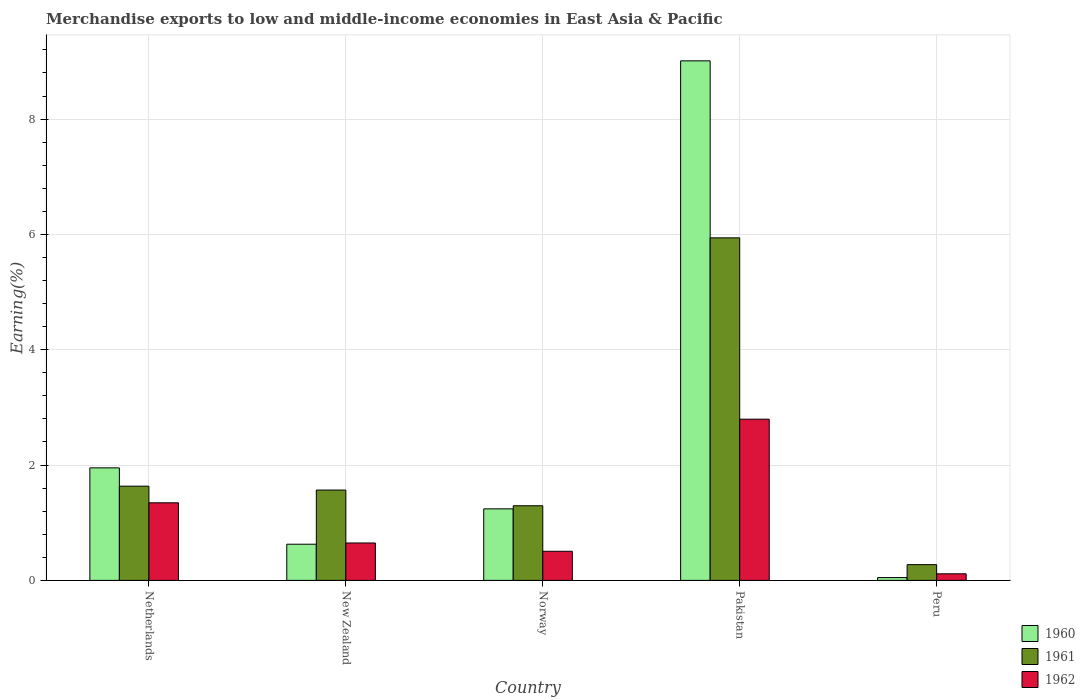How many groups of bars are there?
Give a very brief answer. 5. Are the number of bars per tick equal to the number of legend labels?
Offer a terse response. Yes. How many bars are there on the 2nd tick from the left?
Ensure brevity in your answer.  3. What is the label of the 5th group of bars from the left?
Your answer should be compact. Peru. In how many cases, is the number of bars for a given country not equal to the number of legend labels?
Make the answer very short. 0. What is the percentage of amount earned from merchandise exports in 1962 in Peru?
Your answer should be very brief. 0.11. Across all countries, what is the maximum percentage of amount earned from merchandise exports in 1962?
Offer a very short reply. 2.8. Across all countries, what is the minimum percentage of amount earned from merchandise exports in 1961?
Ensure brevity in your answer.  0.27. What is the total percentage of amount earned from merchandise exports in 1961 in the graph?
Offer a very short reply. 10.71. What is the difference between the percentage of amount earned from merchandise exports in 1961 in New Zealand and that in Pakistan?
Offer a very short reply. -4.37. What is the difference between the percentage of amount earned from merchandise exports in 1960 in New Zealand and the percentage of amount earned from merchandise exports in 1962 in Netherlands?
Ensure brevity in your answer.  -0.72. What is the average percentage of amount earned from merchandise exports in 1960 per country?
Provide a short and direct response. 2.58. What is the difference between the percentage of amount earned from merchandise exports of/in 1962 and percentage of amount earned from merchandise exports of/in 1960 in Norway?
Make the answer very short. -0.74. What is the ratio of the percentage of amount earned from merchandise exports in 1962 in New Zealand to that in Peru?
Your response must be concise. 5.69. Is the percentage of amount earned from merchandise exports in 1962 in Norway less than that in Pakistan?
Provide a succinct answer. Yes. What is the difference between the highest and the second highest percentage of amount earned from merchandise exports in 1960?
Make the answer very short. 7.77. What is the difference between the highest and the lowest percentage of amount earned from merchandise exports in 1960?
Provide a short and direct response. 8.96. Is the sum of the percentage of amount earned from merchandise exports in 1962 in Pakistan and Peru greater than the maximum percentage of amount earned from merchandise exports in 1960 across all countries?
Offer a terse response. No. How many countries are there in the graph?
Your response must be concise. 5. What is the difference between two consecutive major ticks on the Y-axis?
Offer a terse response. 2. Does the graph contain any zero values?
Ensure brevity in your answer.  No. Where does the legend appear in the graph?
Offer a terse response. Bottom right. What is the title of the graph?
Provide a succinct answer. Merchandise exports to low and middle-income economies in East Asia & Pacific. Does "1999" appear as one of the legend labels in the graph?
Make the answer very short. No. What is the label or title of the Y-axis?
Provide a short and direct response. Earning(%). What is the Earning(%) in 1960 in Netherlands?
Offer a terse response. 1.95. What is the Earning(%) in 1961 in Netherlands?
Offer a terse response. 1.63. What is the Earning(%) in 1962 in Netherlands?
Your response must be concise. 1.35. What is the Earning(%) of 1960 in New Zealand?
Provide a short and direct response. 0.63. What is the Earning(%) in 1961 in New Zealand?
Offer a very short reply. 1.57. What is the Earning(%) of 1962 in New Zealand?
Give a very brief answer. 0.65. What is the Earning(%) in 1960 in Norway?
Your answer should be compact. 1.24. What is the Earning(%) in 1961 in Norway?
Keep it short and to the point. 1.29. What is the Earning(%) of 1962 in Norway?
Provide a succinct answer. 0.5. What is the Earning(%) of 1960 in Pakistan?
Your response must be concise. 9.01. What is the Earning(%) in 1961 in Pakistan?
Your answer should be compact. 5.94. What is the Earning(%) in 1962 in Pakistan?
Give a very brief answer. 2.8. What is the Earning(%) of 1960 in Peru?
Your answer should be compact. 0.05. What is the Earning(%) of 1961 in Peru?
Make the answer very short. 0.27. What is the Earning(%) in 1962 in Peru?
Provide a succinct answer. 0.11. Across all countries, what is the maximum Earning(%) of 1960?
Offer a very short reply. 9.01. Across all countries, what is the maximum Earning(%) of 1961?
Your response must be concise. 5.94. Across all countries, what is the maximum Earning(%) in 1962?
Offer a very short reply. 2.8. Across all countries, what is the minimum Earning(%) of 1960?
Give a very brief answer. 0.05. Across all countries, what is the minimum Earning(%) of 1961?
Keep it short and to the point. 0.27. Across all countries, what is the minimum Earning(%) in 1962?
Your answer should be compact. 0.11. What is the total Earning(%) in 1960 in the graph?
Make the answer very short. 12.88. What is the total Earning(%) of 1961 in the graph?
Offer a very short reply. 10.71. What is the total Earning(%) in 1962 in the graph?
Provide a succinct answer. 5.41. What is the difference between the Earning(%) of 1960 in Netherlands and that in New Zealand?
Ensure brevity in your answer.  1.32. What is the difference between the Earning(%) of 1961 in Netherlands and that in New Zealand?
Offer a terse response. 0.07. What is the difference between the Earning(%) of 1962 in Netherlands and that in New Zealand?
Keep it short and to the point. 0.7. What is the difference between the Earning(%) of 1960 in Netherlands and that in Norway?
Your answer should be compact. 0.71. What is the difference between the Earning(%) in 1961 in Netherlands and that in Norway?
Your answer should be compact. 0.34. What is the difference between the Earning(%) of 1962 in Netherlands and that in Norway?
Offer a terse response. 0.84. What is the difference between the Earning(%) of 1960 in Netherlands and that in Pakistan?
Ensure brevity in your answer.  -7.06. What is the difference between the Earning(%) in 1961 in Netherlands and that in Pakistan?
Provide a short and direct response. -4.31. What is the difference between the Earning(%) of 1962 in Netherlands and that in Pakistan?
Your answer should be very brief. -1.45. What is the difference between the Earning(%) of 1960 in Netherlands and that in Peru?
Ensure brevity in your answer.  1.9. What is the difference between the Earning(%) in 1961 in Netherlands and that in Peru?
Keep it short and to the point. 1.36. What is the difference between the Earning(%) in 1962 in Netherlands and that in Peru?
Make the answer very short. 1.23. What is the difference between the Earning(%) in 1960 in New Zealand and that in Norway?
Provide a succinct answer. -0.61. What is the difference between the Earning(%) of 1961 in New Zealand and that in Norway?
Your answer should be compact. 0.27. What is the difference between the Earning(%) of 1962 in New Zealand and that in Norway?
Your answer should be compact. 0.14. What is the difference between the Earning(%) in 1960 in New Zealand and that in Pakistan?
Offer a terse response. -8.38. What is the difference between the Earning(%) in 1961 in New Zealand and that in Pakistan?
Give a very brief answer. -4.37. What is the difference between the Earning(%) of 1962 in New Zealand and that in Pakistan?
Offer a terse response. -2.15. What is the difference between the Earning(%) of 1960 in New Zealand and that in Peru?
Offer a terse response. 0.58. What is the difference between the Earning(%) of 1961 in New Zealand and that in Peru?
Your answer should be compact. 1.29. What is the difference between the Earning(%) in 1962 in New Zealand and that in Peru?
Make the answer very short. 0.53. What is the difference between the Earning(%) in 1960 in Norway and that in Pakistan?
Make the answer very short. -7.77. What is the difference between the Earning(%) in 1961 in Norway and that in Pakistan?
Ensure brevity in your answer.  -4.65. What is the difference between the Earning(%) in 1962 in Norway and that in Pakistan?
Your response must be concise. -2.29. What is the difference between the Earning(%) in 1960 in Norway and that in Peru?
Provide a succinct answer. 1.19. What is the difference between the Earning(%) in 1961 in Norway and that in Peru?
Your response must be concise. 1.02. What is the difference between the Earning(%) of 1962 in Norway and that in Peru?
Your answer should be very brief. 0.39. What is the difference between the Earning(%) in 1960 in Pakistan and that in Peru?
Give a very brief answer. 8.96. What is the difference between the Earning(%) in 1961 in Pakistan and that in Peru?
Offer a terse response. 5.67. What is the difference between the Earning(%) of 1962 in Pakistan and that in Peru?
Offer a terse response. 2.68. What is the difference between the Earning(%) of 1960 in Netherlands and the Earning(%) of 1961 in New Zealand?
Provide a short and direct response. 0.39. What is the difference between the Earning(%) in 1960 in Netherlands and the Earning(%) in 1962 in New Zealand?
Offer a very short reply. 1.3. What is the difference between the Earning(%) in 1960 in Netherlands and the Earning(%) in 1961 in Norway?
Your response must be concise. 0.66. What is the difference between the Earning(%) in 1960 in Netherlands and the Earning(%) in 1962 in Norway?
Make the answer very short. 1.45. What is the difference between the Earning(%) of 1961 in Netherlands and the Earning(%) of 1962 in Norway?
Your response must be concise. 1.13. What is the difference between the Earning(%) of 1960 in Netherlands and the Earning(%) of 1961 in Pakistan?
Ensure brevity in your answer.  -3.99. What is the difference between the Earning(%) of 1960 in Netherlands and the Earning(%) of 1962 in Pakistan?
Keep it short and to the point. -0.84. What is the difference between the Earning(%) of 1961 in Netherlands and the Earning(%) of 1962 in Pakistan?
Keep it short and to the point. -1.16. What is the difference between the Earning(%) of 1960 in Netherlands and the Earning(%) of 1961 in Peru?
Ensure brevity in your answer.  1.68. What is the difference between the Earning(%) in 1960 in Netherlands and the Earning(%) in 1962 in Peru?
Make the answer very short. 1.84. What is the difference between the Earning(%) of 1961 in Netherlands and the Earning(%) of 1962 in Peru?
Offer a terse response. 1.52. What is the difference between the Earning(%) in 1960 in New Zealand and the Earning(%) in 1961 in Norway?
Your response must be concise. -0.67. What is the difference between the Earning(%) in 1960 in New Zealand and the Earning(%) in 1962 in Norway?
Provide a short and direct response. 0.12. What is the difference between the Earning(%) in 1961 in New Zealand and the Earning(%) in 1962 in Norway?
Provide a short and direct response. 1.06. What is the difference between the Earning(%) in 1960 in New Zealand and the Earning(%) in 1961 in Pakistan?
Make the answer very short. -5.31. What is the difference between the Earning(%) of 1960 in New Zealand and the Earning(%) of 1962 in Pakistan?
Give a very brief answer. -2.17. What is the difference between the Earning(%) in 1961 in New Zealand and the Earning(%) in 1962 in Pakistan?
Your answer should be very brief. -1.23. What is the difference between the Earning(%) of 1960 in New Zealand and the Earning(%) of 1961 in Peru?
Make the answer very short. 0.35. What is the difference between the Earning(%) in 1960 in New Zealand and the Earning(%) in 1962 in Peru?
Offer a terse response. 0.51. What is the difference between the Earning(%) of 1961 in New Zealand and the Earning(%) of 1962 in Peru?
Offer a very short reply. 1.45. What is the difference between the Earning(%) in 1960 in Norway and the Earning(%) in 1961 in Pakistan?
Your answer should be compact. -4.7. What is the difference between the Earning(%) in 1960 in Norway and the Earning(%) in 1962 in Pakistan?
Keep it short and to the point. -1.56. What is the difference between the Earning(%) in 1961 in Norway and the Earning(%) in 1962 in Pakistan?
Your answer should be compact. -1.5. What is the difference between the Earning(%) of 1960 in Norway and the Earning(%) of 1962 in Peru?
Your answer should be very brief. 1.13. What is the difference between the Earning(%) of 1961 in Norway and the Earning(%) of 1962 in Peru?
Your response must be concise. 1.18. What is the difference between the Earning(%) of 1960 in Pakistan and the Earning(%) of 1961 in Peru?
Offer a terse response. 8.74. What is the difference between the Earning(%) in 1960 in Pakistan and the Earning(%) in 1962 in Peru?
Your answer should be very brief. 8.9. What is the difference between the Earning(%) of 1961 in Pakistan and the Earning(%) of 1962 in Peru?
Keep it short and to the point. 5.83. What is the average Earning(%) of 1960 per country?
Your response must be concise. 2.58. What is the average Earning(%) in 1961 per country?
Keep it short and to the point. 2.14. What is the average Earning(%) in 1962 per country?
Your answer should be very brief. 1.08. What is the difference between the Earning(%) in 1960 and Earning(%) in 1961 in Netherlands?
Make the answer very short. 0.32. What is the difference between the Earning(%) in 1960 and Earning(%) in 1962 in Netherlands?
Offer a terse response. 0.61. What is the difference between the Earning(%) of 1961 and Earning(%) of 1962 in Netherlands?
Give a very brief answer. 0.29. What is the difference between the Earning(%) in 1960 and Earning(%) in 1961 in New Zealand?
Provide a succinct answer. -0.94. What is the difference between the Earning(%) in 1960 and Earning(%) in 1962 in New Zealand?
Your answer should be very brief. -0.02. What is the difference between the Earning(%) of 1961 and Earning(%) of 1962 in New Zealand?
Your answer should be very brief. 0.92. What is the difference between the Earning(%) of 1960 and Earning(%) of 1961 in Norway?
Provide a short and direct response. -0.05. What is the difference between the Earning(%) of 1960 and Earning(%) of 1962 in Norway?
Give a very brief answer. 0.74. What is the difference between the Earning(%) of 1961 and Earning(%) of 1962 in Norway?
Ensure brevity in your answer.  0.79. What is the difference between the Earning(%) in 1960 and Earning(%) in 1961 in Pakistan?
Your response must be concise. 3.07. What is the difference between the Earning(%) in 1960 and Earning(%) in 1962 in Pakistan?
Your response must be concise. 6.21. What is the difference between the Earning(%) of 1961 and Earning(%) of 1962 in Pakistan?
Your answer should be compact. 3.14. What is the difference between the Earning(%) in 1960 and Earning(%) in 1961 in Peru?
Provide a succinct answer. -0.22. What is the difference between the Earning(%) in 1960 and Earning(%) in 1962 in Peru?
Make the answer very short. -0.07. What is the difference between the Earning(%) of 1961 and Earning(%) of 1962 in Peru?
Keep it short and to the point. 0.16. What is the ratio of the Earning(%) in 1960 in Netherlands to that in New Zealand?
Make the answer very short. 3.11. What is the ratio of the Earning(%) of 1961 in Netherlands to that in New Zealand?
Ensure brevity in your answer.  1.04. What is the ratio of the Earning(%) of 1962 in Netherlands to that in New Zealand?
Your answer should be very brief. 2.07. What is the ratio of the Earning(%) in 1960 in Netherlands to that in Norway?
Offer a terse response. 1.57. What is the ratio of the Earning(%) in 1961 in Netherlands to that in Norway?
Provide a short and direct response. 1.26. What is the ratio of the Earning(%) of 1962 in Netherlands to that in Norway?
Ensure brevity in your answer.  2.67. What is the ratio of the Earning(%) of 1960 in Netherlands to that in Pakistan?
Provide a succinct answer. 0.22. What is the ratio of the Earning(%) of 1961 in Netherlands to that in Pakistan?
Give a very brief answer. 0.28. What is the ratio of the Earning(%) in 1962 in Netherlands to that in Pakistan?
Your response must be concise. 0.48. What is the ratio of the Earning(%) in 1960 in Netherlands to that in Peru?
Make the answer very short. 39.89. What is the ratio of the Earning(%) in 1961 in Netherlands to that in Peru?
Provide a short and direct response. 5.99. What is the ratio of the Earning(%) of 1962 in Netherlands to that in Peru?
Provide a short and direct response. 11.79. What is the ratio of the Earning(%) of 1960 in New Zealand to that in Norway?
Offer a very short reply. 0.51. What is the ratio of the Earning(%) of 1961 in New Zealand to that in Norway?
Your answer should be compact. 1.21. What is the ratio of the Earning(%) in 1962 in New Zealand to that in Norway?
Offer a terse response. 1.29. What is the ratio of the Earning(%) in 1960 in New Zealand to that in Pakistan?
Your response must be concise. 0.07. What is the ratio of the Earning(%) of 1961 in New Zealand to that in Pakistan?
Offer a very short reply. 0.26. What is the ratio of the Earning(%) of 1962 in New Zealand to that in Pakistan?
Provide a succinct answer. 0.23. What is the ratio of the Earning(%) of 1960 in New Zealand to that in Peru?
Make the answer very short. 12.82. What is the ratio of the Earning(%) in 1961 in New Zealand to that in Peru?
Make the answer very short. 5.74. What is the ratio of the Earning(%) in 1962 in New Zealand to that in Peru?
Your answer should be compact. 5.69. What is the ratio of the Earning(%) of 1960 in Norway to that in Pakistan?
Offer a terse response. 0.14. What is the ratio of the Earning(%) of 1961 in Norway to that in Pakistan?
Your answer should be very brief. 0.22. What is the ratio of the Earning(%) in 1962 in Norway to that in Pakistan?
Provide a short and direct response. 0.18. What is the ratio of the Earning(%) in 1960 in Norway to that in Peru?
Your answer should be compact. 25.36. What is the ratio of the Earning(%) in 1961 in Norway to that in Peru?
Provide a short and direct response. 4.74. What is the ratio of the Earning(%) of 1962 in Norway to that in Peru?
Provide a short and direct response. 4.42. What is the ratio of the Earning(%) of 1960 in Pakistan to that in Peru?
Give a very brief answer. 184.16. What is the ratio of the Earning(%) of 1961 in Pakistan to that in Peru?
Provide a succinct answer. 21.77. What is the ratio of the Earning(%) in 1962 in Pakistan to that in Peru?
Give a very brief answer. 24.5. What is the difference between the highest and the second highest Earning(%) in 1960?
Your answer should be very brief. 7.06. What is the difference between the highest and the second highest Earning(%) in 1961?
Offer a very short reply. 4.31. What is the difference between the highest and the second highest Earning(%) in 1962?
Your response must be concise. 1.45. What is the difference between the highest and the lowest Earning(%) in 1960?
Make the answer very short. 8.96. What is the difference between the highest and the lowest Earning(%) in 1961?
Your response must be concise. 5.67. What is the difference between the highest and the lowest Earning(%) in 1962?
Your response must be concise. 2.68. 